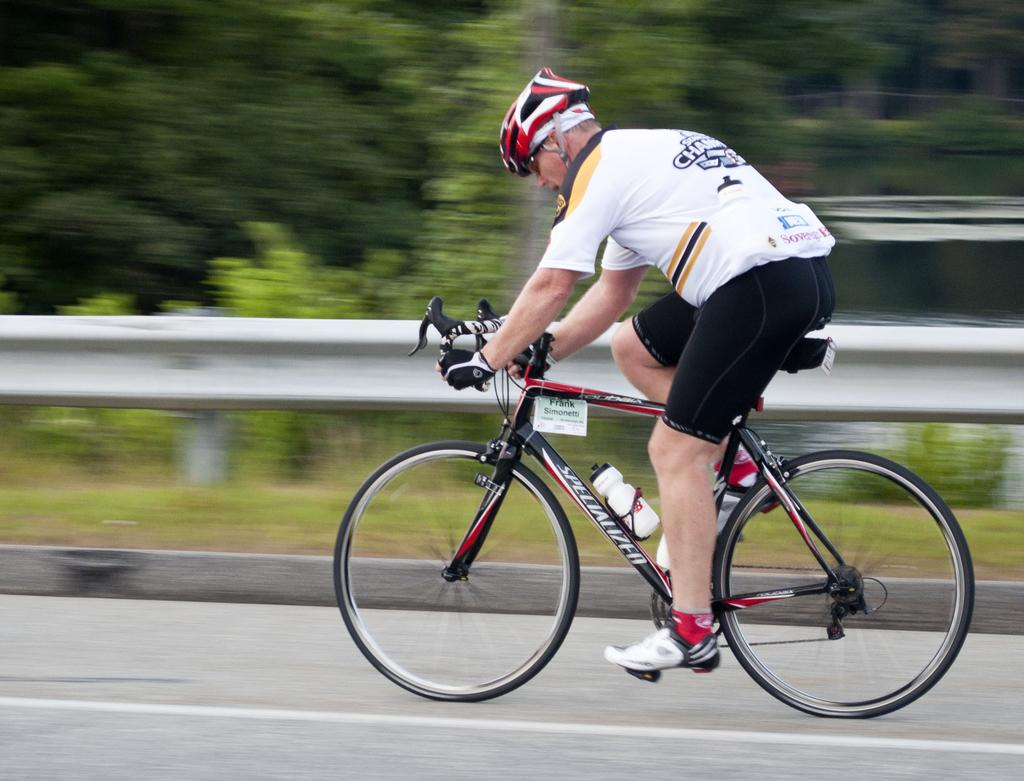What is the main subject of the image? The main subject of the image is a man. What protective gear is the man wearing? The man is wearing a helmet, gloves, and shoes. What is the man doing in the image? The man is riding a bicycle. Where is the bicycle located? The bicycle is on the road. What can be seen in the background of the image? There are trees visible in the background of the image, and the background appears blurry. How far away is the cannon from the man in the image? There is no cannon present in the image, so it cannot be determined how far away it might be from the man. 